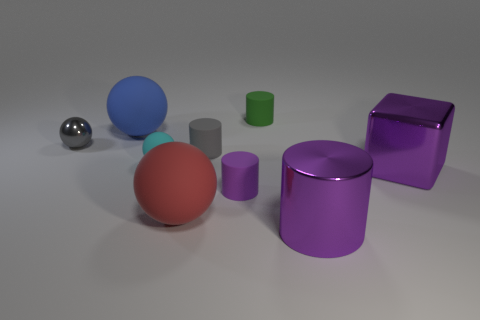There is a big matte thing that is to the left of the large red matte sphere; is it the same color as the large metallic cylinder?
Offer a terse response. No. How many objects are either small matte cylinders or tiny gray metallic spheres?
Ensure brevity in your answer.  4. The big matte object that is behind the big purple metallic block is what color?
Make the answer very short. Blue. Are there fewer blue things in front of the small cyan rubber ball than tiny yellow shiny things?
Your answer should be compact. No. The rubber thing that is the same color as the small metallic object is what size?
Make the answer very short. Small. Are there any other things that have the same size as the red rubber ball?
Your response must be concise. Yes. Do the tiny cyan ball and the green cylinder have the same material?
Make the answer very short. Yes. How many things are either tiny matte things that are behind the big blue object or large things in front of the metal cube?
Your response must be concise. 3. Are there any other matte things that have the same size as the green rubber object?
Your answer should be compact. Yes. What color is the small shiny thing that is the same shape as the large red object?
Your answer should be compact. Gray. 